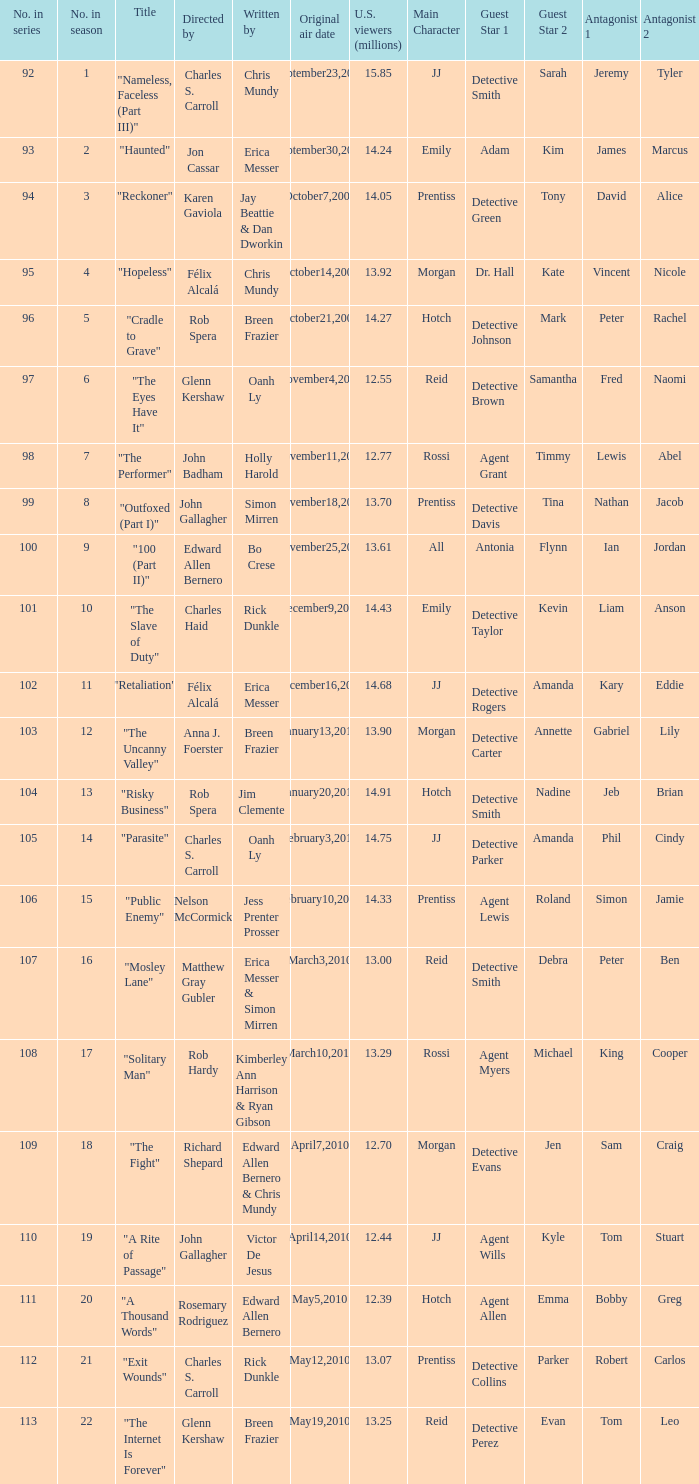What was the first episode in the season directed by nelson mccormick? 15.0. 